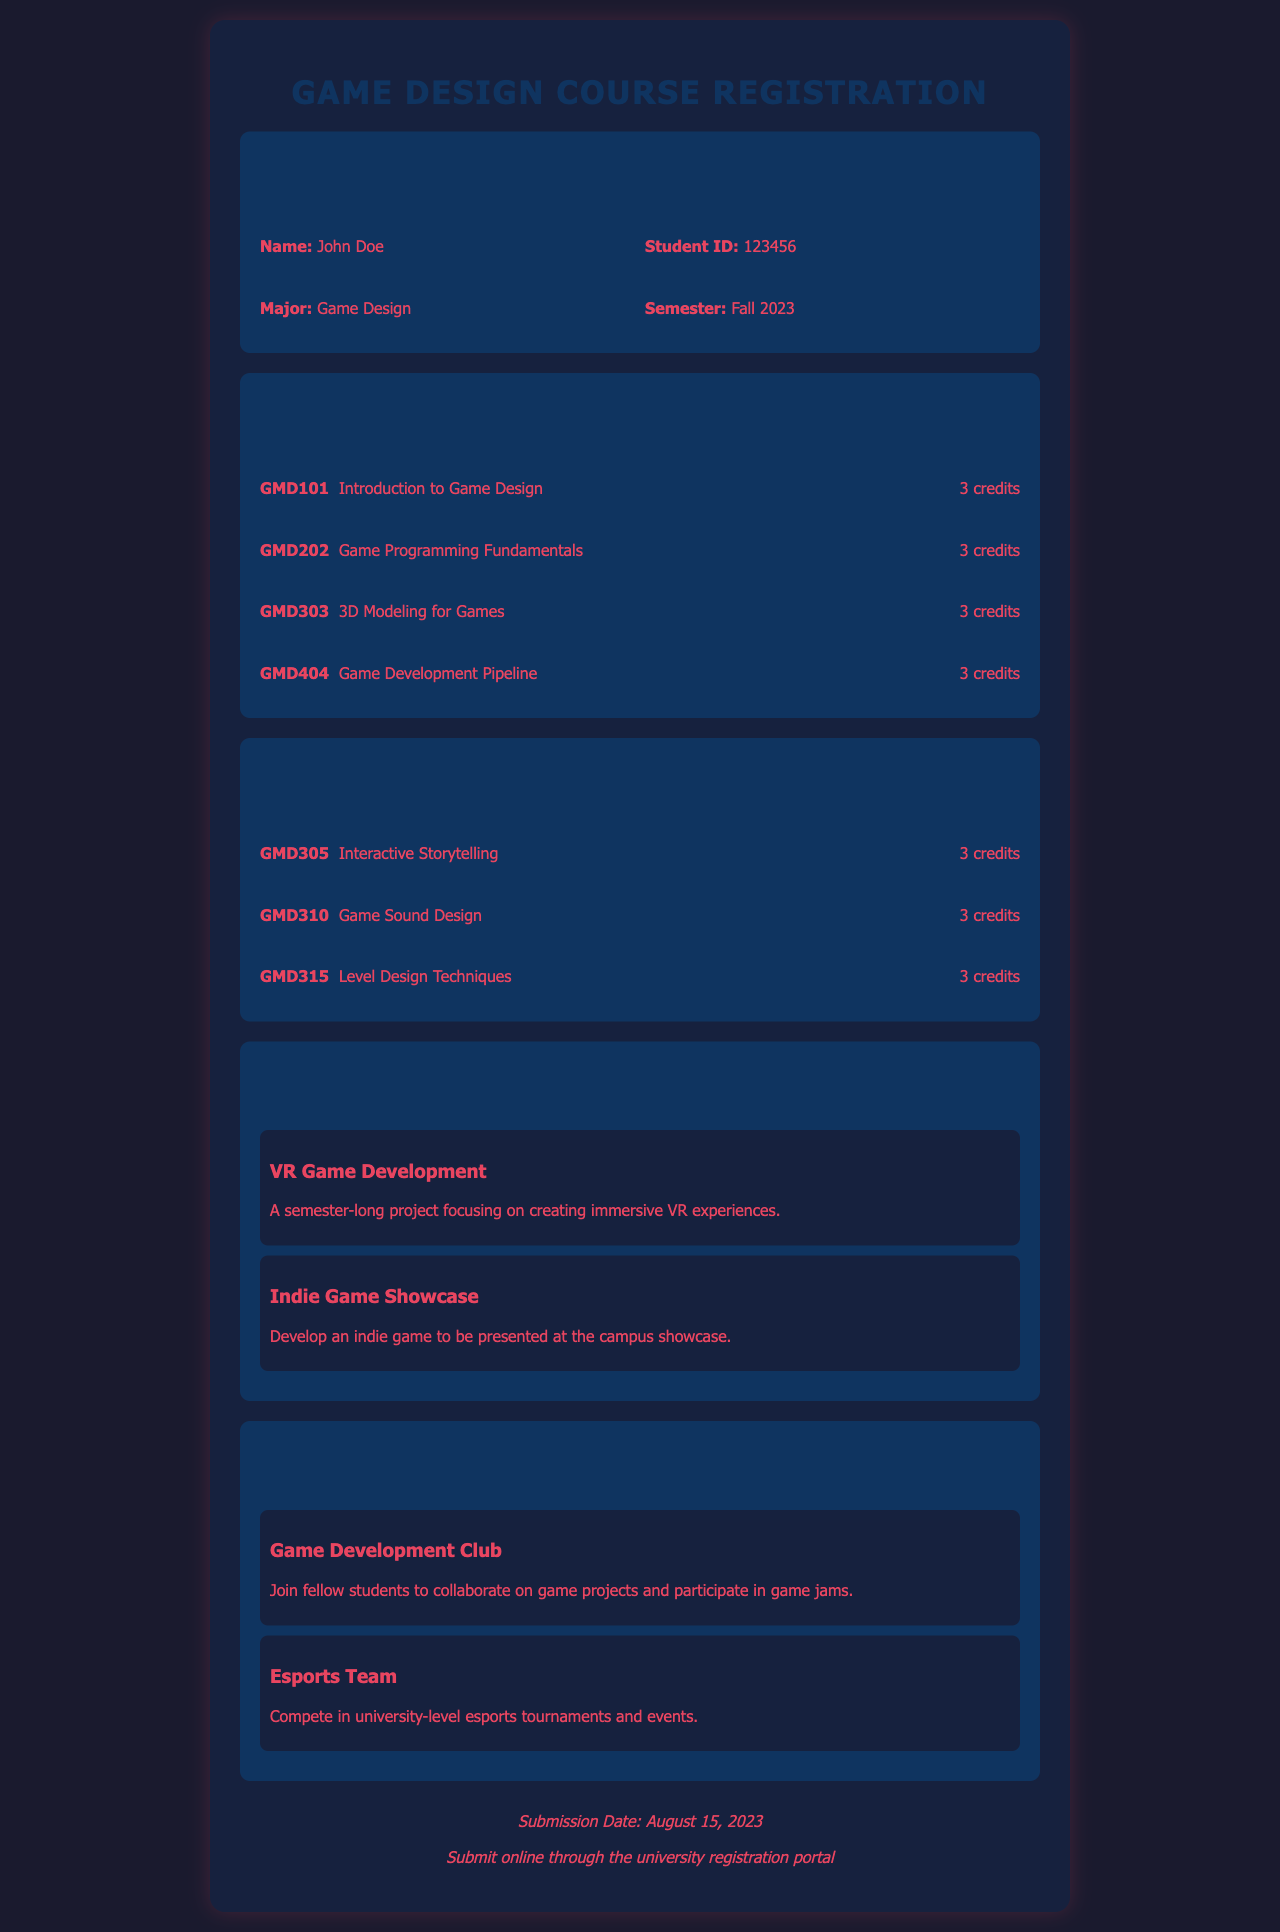What is the student's name? The student's name is mentioned in the student information section of the document.
Answer: John Doe How many core courses are listed? The document lists four core courses under the core courses section.
Answer: 4 What is the title of the second elective class? The titles of the elective classes are found in the elective classes section, specifically the second one.
Answer: Game Sound Design What is the submission date for the registration? The submission date is specified at the bottom of the document.
Answer: August 15, 2023 What is the focus of the "VR Game Development" project? The focus of the project can be found in the special projects section of the document.
Answer: Creating immersive VR experiences Which extracurricular activity involves competing in tournaments? The extracurricular activities section mentions which activity is tournament-related.
Answer: Esports Team How many credits are awarded for "Level Design Techniques"? The number of credits for courses can be found next to the course titles in the elective classes section.
Answer: 3 credits What is the student's major? The student's major is part of the information provided in the student information section.
Answer: Game Design Which club allows collaboration on game projects? The document explicitly states which club is for collaborating on game projects.
Answer: Game Development Club 